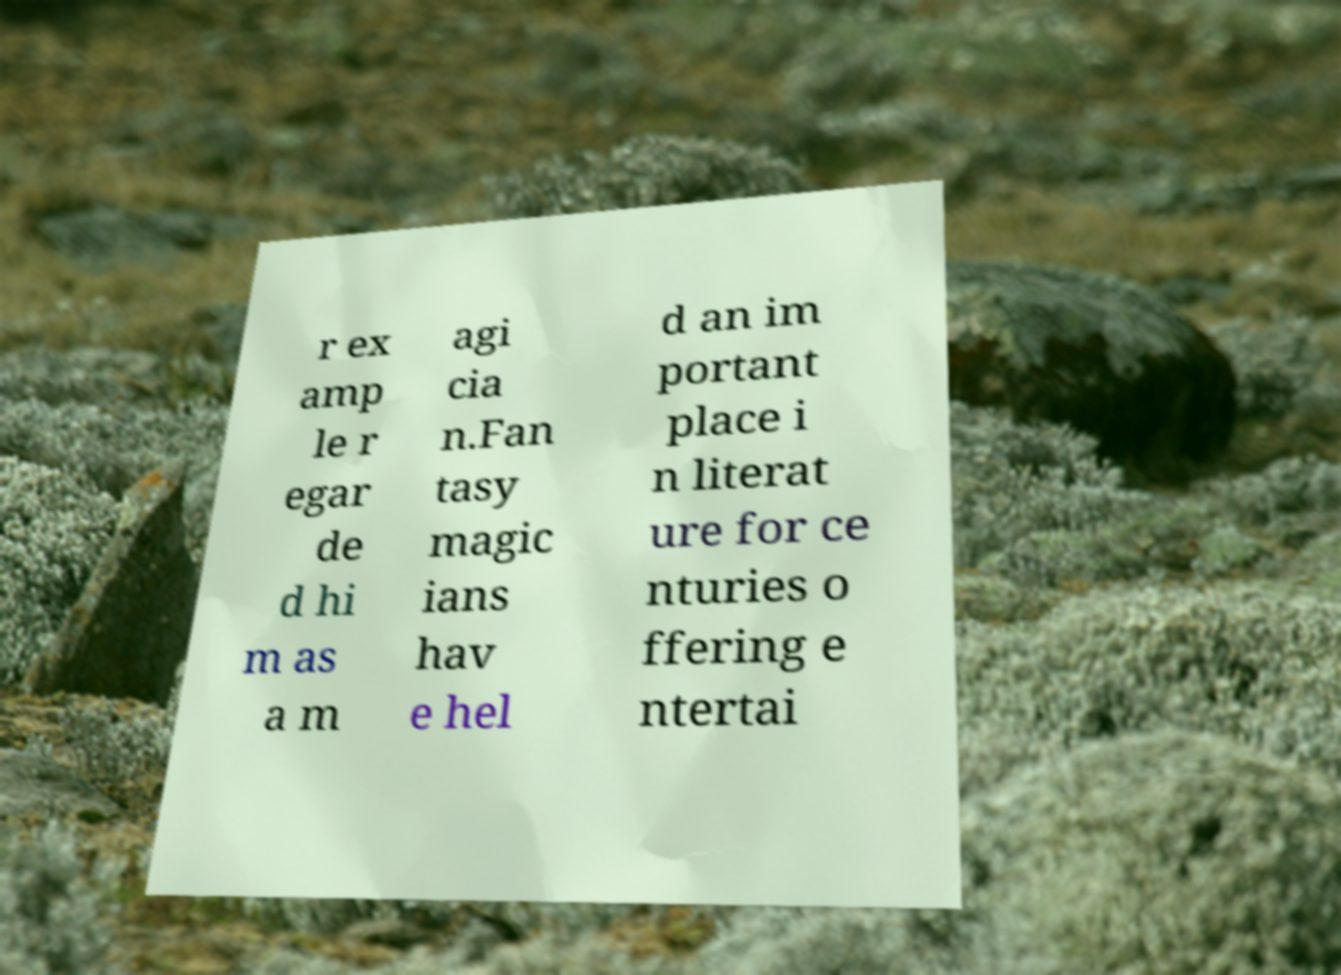Please read and relay the text visible in this image. What does it say? r ex amp le r egar de d hi m as a m agi cia n.Fan tasy magic ians hav e hel d an im portant place i n literat ure for ce nturies o ffering e ntertai 